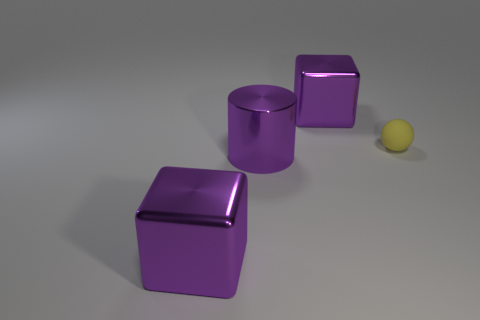Does the small matte object have the same shape as the metal thing that is behind the purple cylinder?
Your answer should be very brief. No. What number of other things are the same size as the purple cylinder?
Keep it short and to the point. 2. Are there more large green metal blocks than matte objects?
Ensure brevity in your answer.  No. How many purple cubes are behind the yellow rubber object and in front of the matte ball?
Your answer should be very brief. 0. There is a large object that is right of the large purple cylinder in front of the purple object that is behind the rubber object; what shape is it?
Ensure brevity in your answer.  Cube. Is there anything else that is the same shape as the small object?
Your answer should be compact. No. How many cubes are tiny things or large purple objects?
Offer a very short reply. 2. There is a block in front of the yellow rubber sphere; is its color the same as the metal cylinder?
Make the answer very short. Yes. The big block behind the purple block that is left of the purple cube that is behind the big cylinder is made of what material?
Offer a terse response. Metal. Do the sphere and the purple cylinder have the same size?
Give a very brief answer. No. 